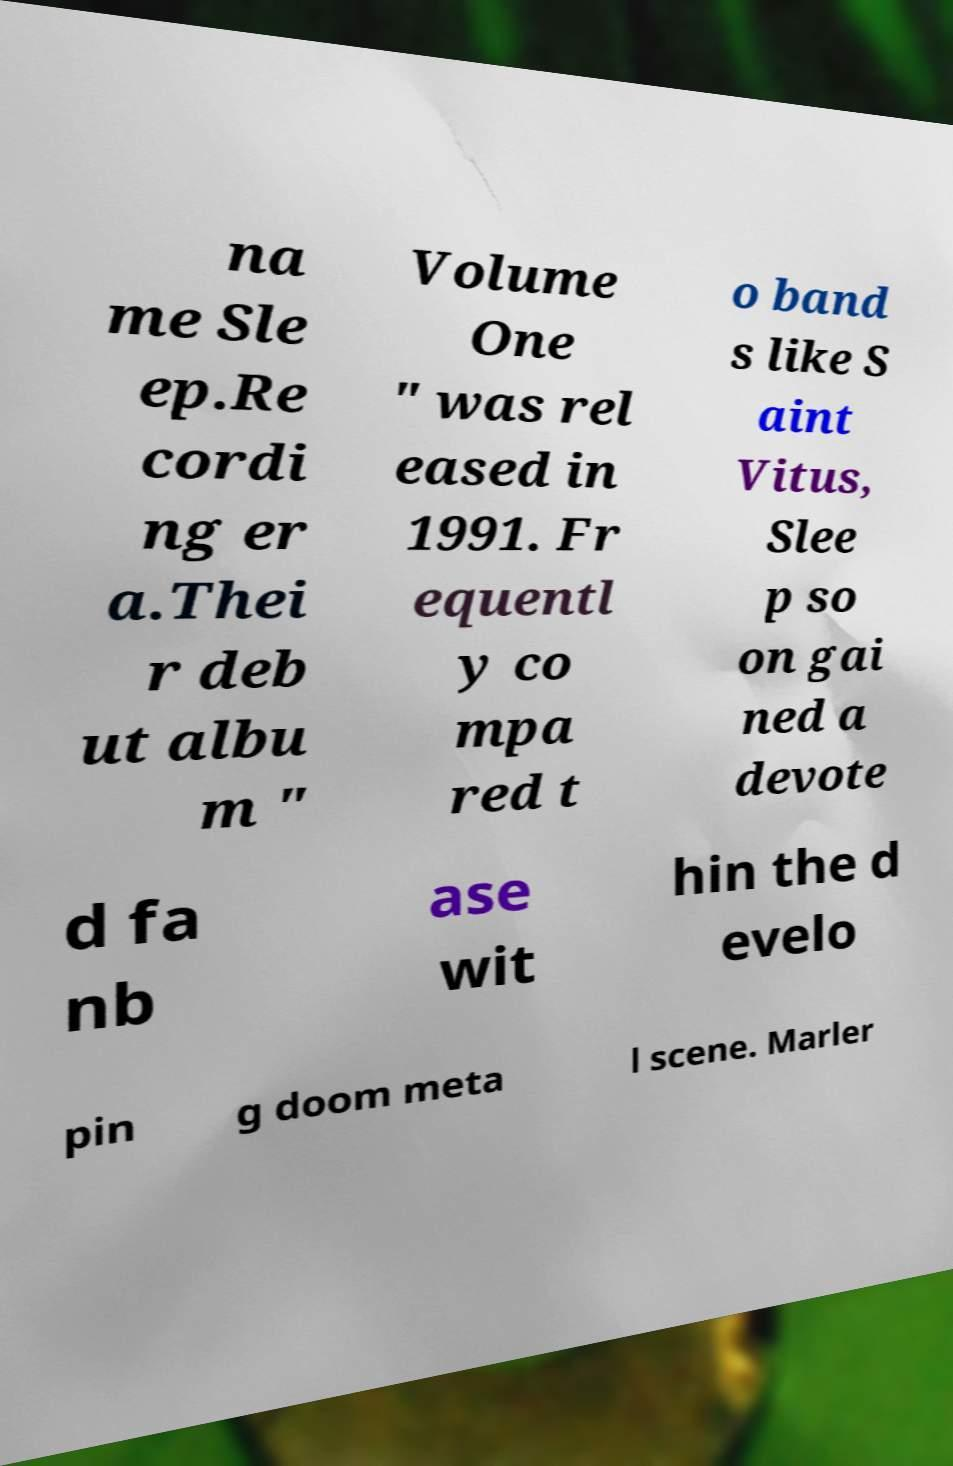Could you extract and type out the text from this image? na me Sle ep.Re cordi ng er a.Thei r deb ut albu m " Volume One " was rel eased in 1991. Fr equentl y co mpa red t o band s like S aint Vitus, Slee p so on gai ned a devote d fa nb ase wit hin the d evelo pin g doom meta l scene. Marler 